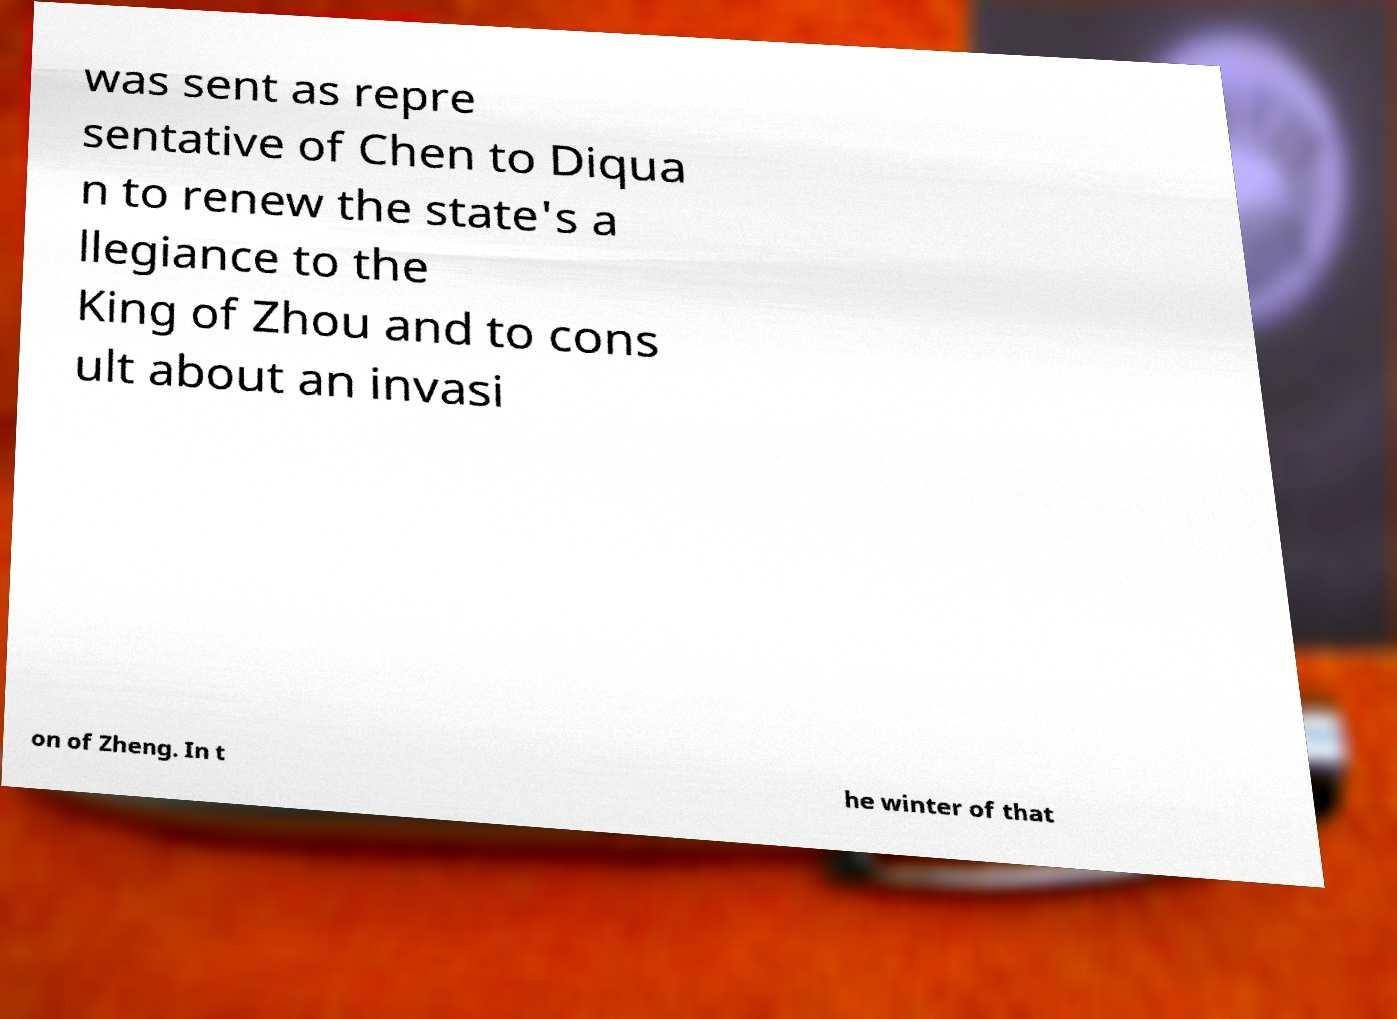There's text embedded in this image that I need extracted. Can you transcribe it verbatim? was sent as repre sentative of Chen to Diqua n to renew the state's a llegiance to the King of Zhou and to cons ult about an invasi on of Zheng. In t he winter of that 